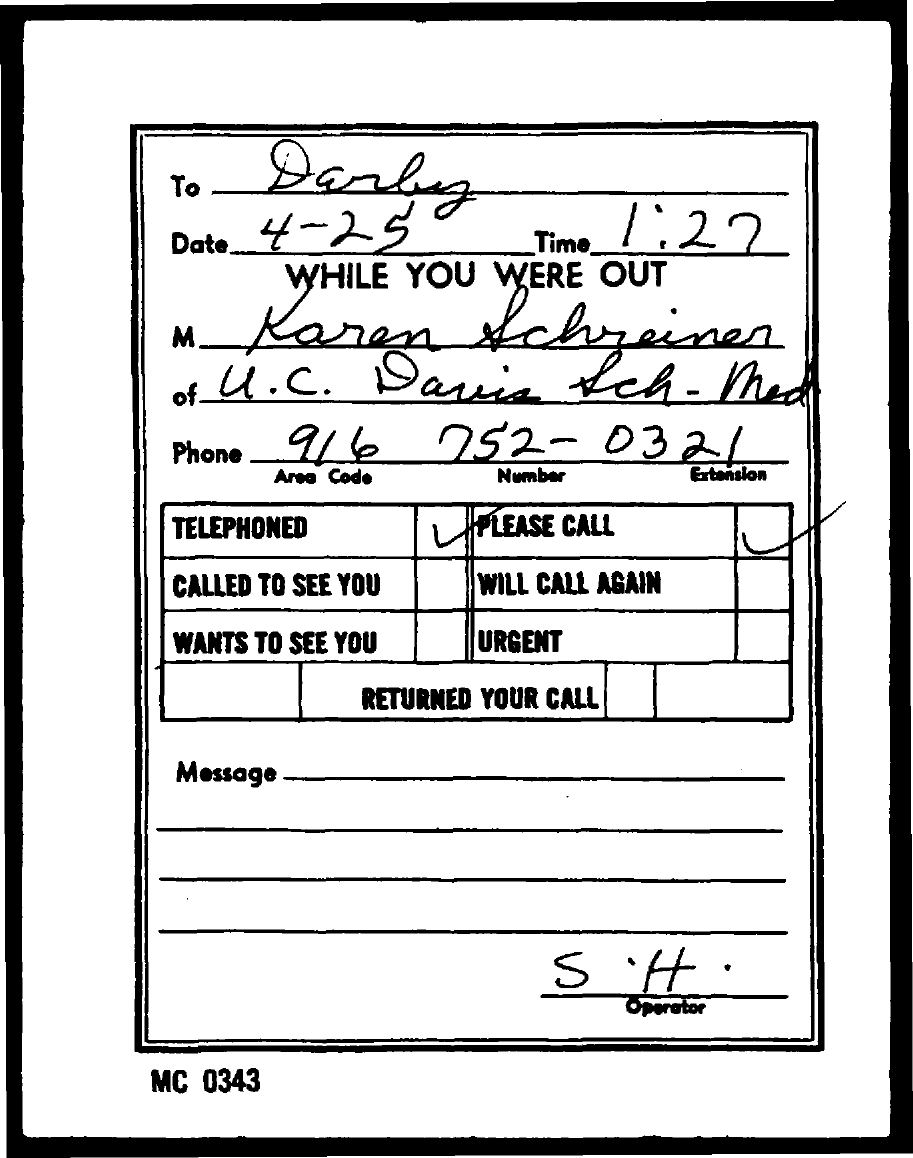Outline some significant characteristics in this image. The time given is 1:27... The code mentioned at the bottom of the page is MC 0343. 